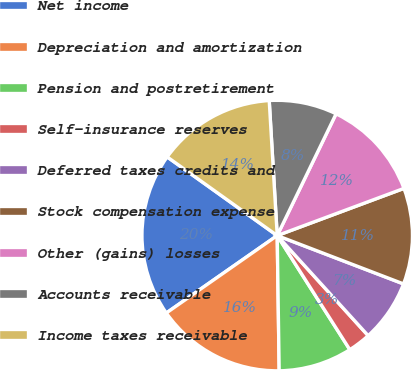<chart> <loc_0><loc_0><loc_500><loc_500><pie_chart><fcel>Net income<fcel>Depreciation and amortization<fcel>Pension and postretirement<fcel>Self-insurance reserves<fcel>Deferred taxes credits and<fcel>Stock compensation expense<fcel>Other (gains) losses<fcel>Accounts receivable<fcel>Income taxes receivable<nl><fcel>19.58%<fcel>15.53%<fcel>8.79%<fcel>2.72%<fcel>7.44%<fcel>11.49%<fcel>12.16%<fcel>8.11%<fcel>14.18%<nl></chart> 